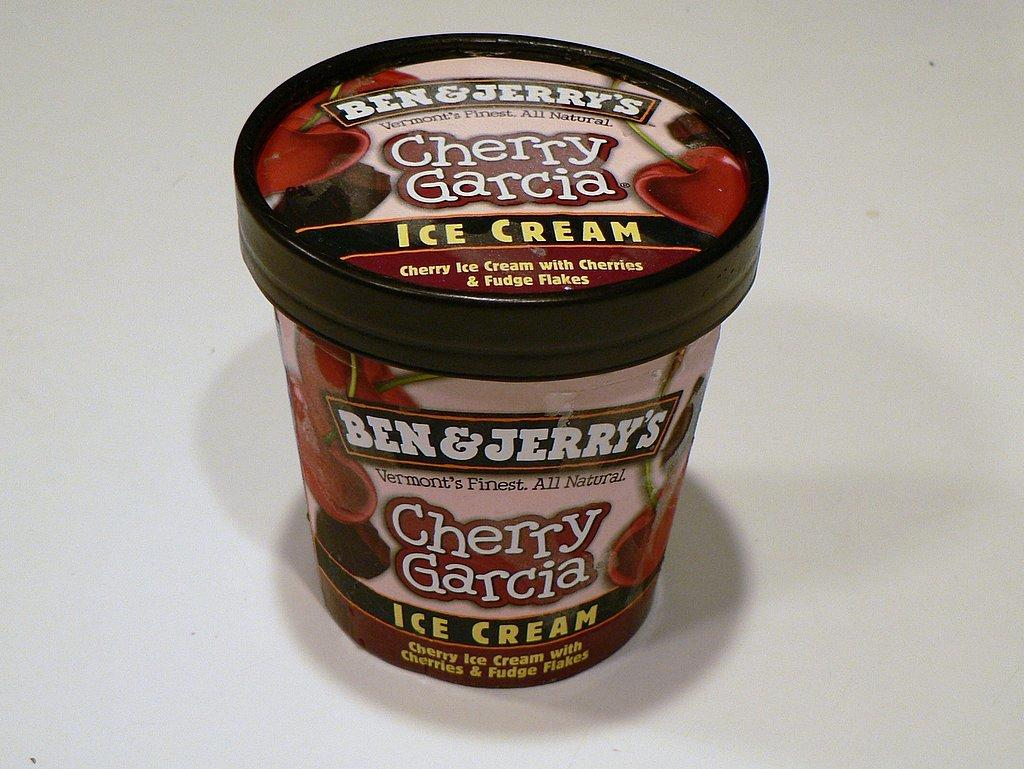What object is present in the image? There is a box in the image. What colors are visible on the box? The box has red and black colors. What color is the background of the image? The background of the image is white. How many divisions are present in the box in the image? There is no indication of divisions within the box in the image. What parent is shown with the box in the image? There are no people, including parents, present in the image. 